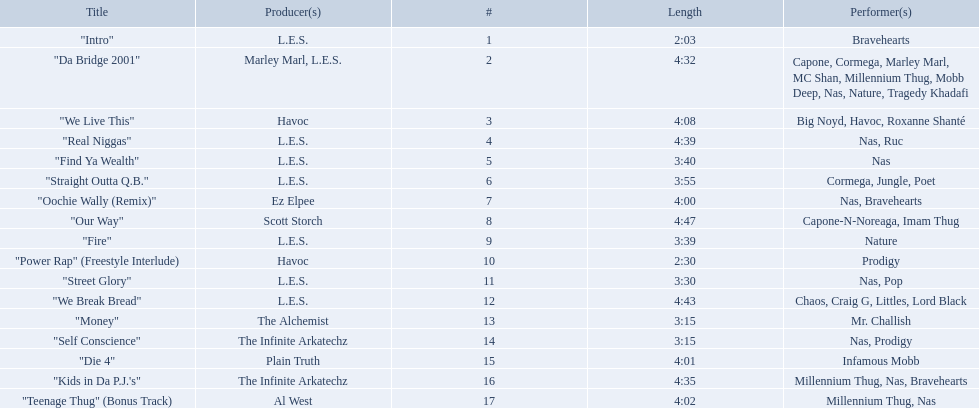What are the track times on the nas & ill will records presents qb's finest album? 2:03, 4:32, 4:08, 4:39, 3:40, 3:55, 4:00, 4:47, 3:39, 2:30, 3:30, 4:43, 3:15, 3:15, 4:01, 4:35, 4:02. Of those which is the longest? 4:47. 